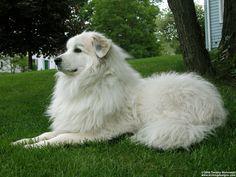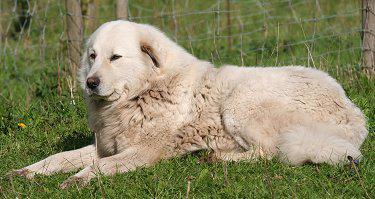The first image is the image on the left, the second image is the image on the right. For the images shown, is this caption "Atleast one dog is sitting next to a pile of hair." true? Answer yes or no. No. The first image is the image on the left, the second image is the image on the right. Given the left and right images, does the statement "There are piles of fur on the floor in at least one picture." hold true? Answer yes or no. No. 